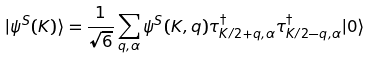Convert formula to latex. <formula><loc_0><loc_0><loc_500><loc_500>| \psi ^ { S } ( { K } ) \rangle = \frac { 1 } { \sqrt { 6 } } \sum _ { { q } , \alpha } \psi ^ { S } ( { K } , { q } ) \tau ^ { \dagger } _ { { K } / 2 + { q } , \alpha } \tau ^ { \dagger } _ { { K } / 2 - { q } , \alpha } | 0 \rangle</formula> 